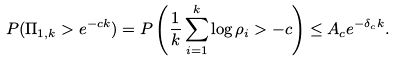Convert formula to latex. <formula><loc_0><loc_0><loc_500><loc_500>P ( \Pi _ { 1 , k } > e ^ { - c k } ) = P \left ( \frac { 1 } { k } \sum _ { i = 1 } ^ { k } \log \rho _ { i } > - c \right ) \leq A _ { c } e ^ { - \delta _ { c } k } .</formula> 